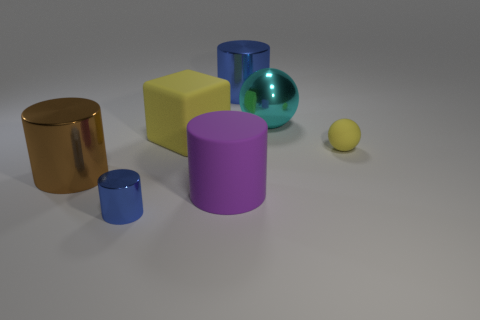What number of matte things are right of the blue cylinder behind the brown metallic cylinder?
Provide a succinct answer. 1. Are any large gray metallic cubes visible?
Keep it short and to the point. No. Are there any large brown balls that have the same material as the cyan object?
Ensure brevity in your answer.  No. Is the number of metallic cylinders that are on the left side of the large yellow block greater than the number of metal objects that are to the left of the cyan thing?
Offer a terse response. No. Do the cyan shiny sphere and the brown metal thing have the same size?
Your response must be concise. Yes. What is the color of the big shiny cylinder that is in front of the large metallic cylinder that is on the right side of the yellow rubber block?
Give a very brief answer. Brown. The block has what color?
Your response must be concise. Yellow. Are there any spheres of the same color as the large block?
Ensure brevity in your answer.  Yes. There is a metallic cylinder that is behind the cube; does it have the same color as the tiny metal thing?
Give a very brief answer. Yes. How many things are either big cylinders behind the large brown shiny object or small gray shiny blocks?
Keep it short and to the point. 1. 